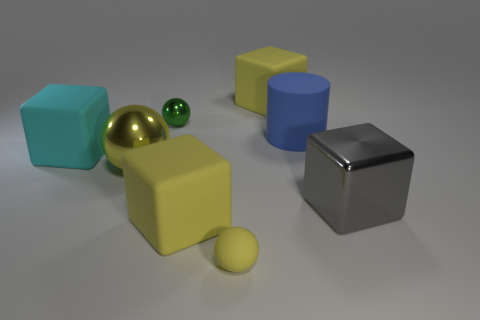How many objects are behind the big yellow matte thing in front of the big yellow block behind the cyan rubber block?
Keep it short and to the point. 6. How many metal things are big cyan things or yellow cubes?
Offer a very short reply. 0. What is the color of the rubber thing that is both in front of the big yellow metal object and behind the tiny matte thing?
Offer a very short reply. Yellow. Do the yellow object that is behind the rubber cylinder and the cyan cube have the same size?
Your response must be concise. Yes. What number of things are either shiny objects that are in front of the big metallic ball or cubes?
Provide a succinct answer. 4. Is there a cyan matte block that has the same size as the metal cube?
Make the answer very short. Yes. There is a object that is the same size as the yellow rubber ball; what material is it?
Provide a succinct answer. Metal. There is a thing that is to the right of the tiny yellow ball and behind the big blue cylinder; what is its shape?
Give a very brief answer. Cube. There is a small object that is behind the large shiny ball; what is its color?
Keep it short and to the point. Green. There is a cube that is in front of the big cyan matte thing and on the right side of the tiny yellow object; what size is it?
Your response must be concise. Large. 